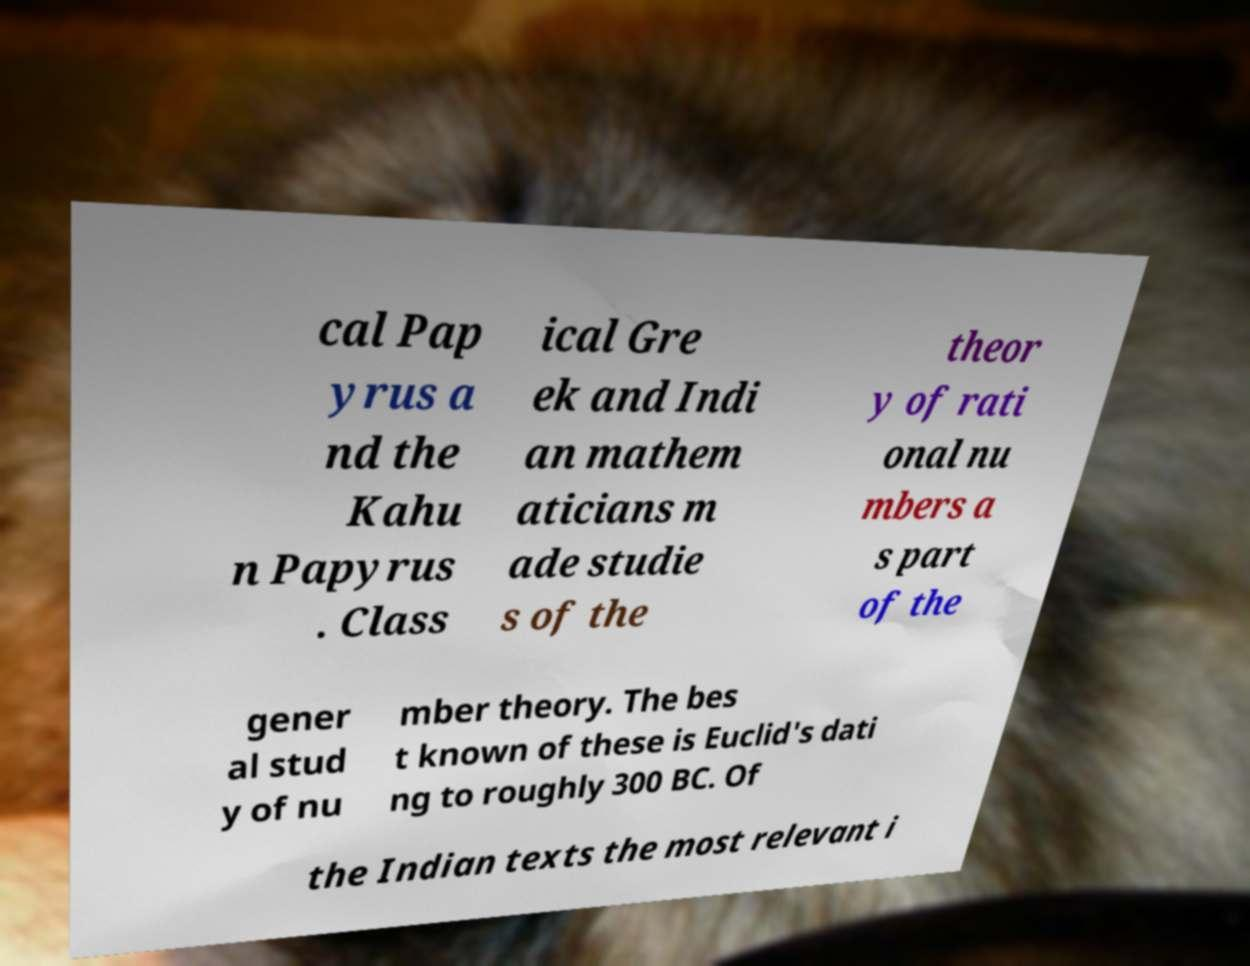Could you extract and type out the text from this image? cal Pap yrus a nd the Kahu n Papyrus . Class ical Gre ek and Indi an mathem aticians m ade studie s of the theor y of rati onal nu mbers a s part of the gener al stud y of nu mber theory. The bes t known of these is Euclid's dati ng to roughly 300 BC. Of the Indian texts the most relevant i 